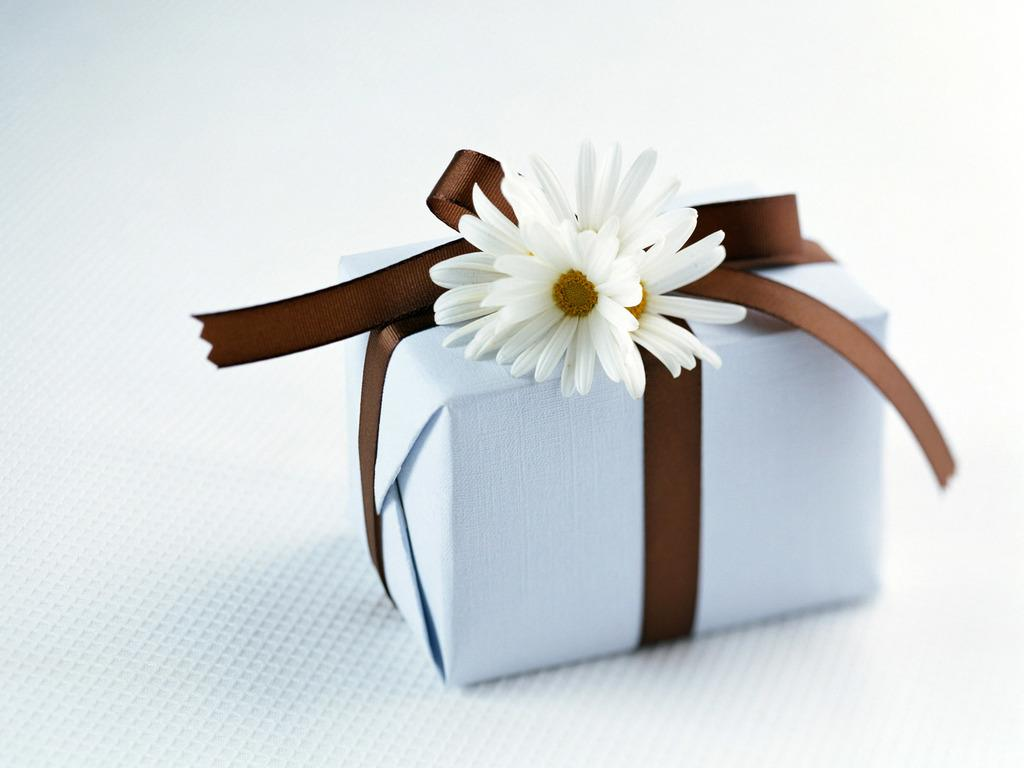What is the main object in the image? There is a white gift box in the image. How is the gift box decorated? The gift box is wrapped with a brown ribbon and has white flowers on it. What is the color of the background in the image? The background of the image is white. Can you see any grass growing in the image? There is no grass present in the image; it features a white gift box with a brown ribbon and white flowers against a white background. 